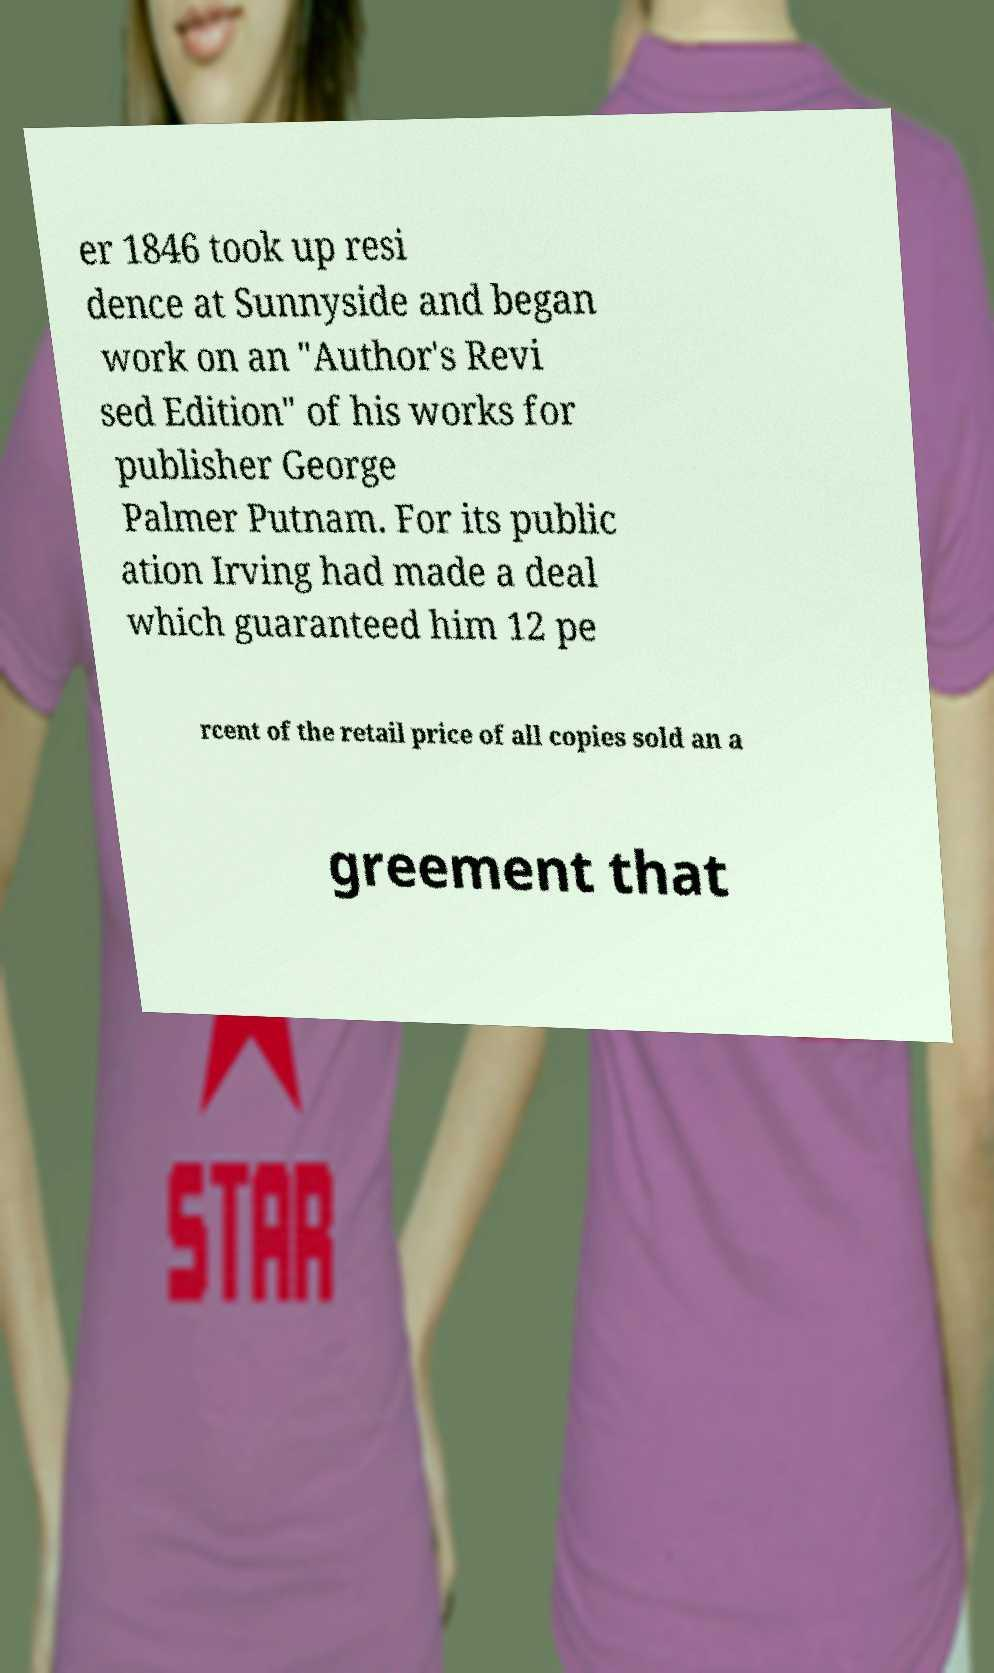There's text embedded in this image that I need extracted. Can you transcribe it verbatim? er 1846 took up resi dence at Sunnyside and began work on an "Author's Revi sed Edition" of his works for publisher George Palmer Putnam. For its public ation Irving had made a deal which guaranteed him 12 pe rcent of the retail price of all copies sold an a greement that 